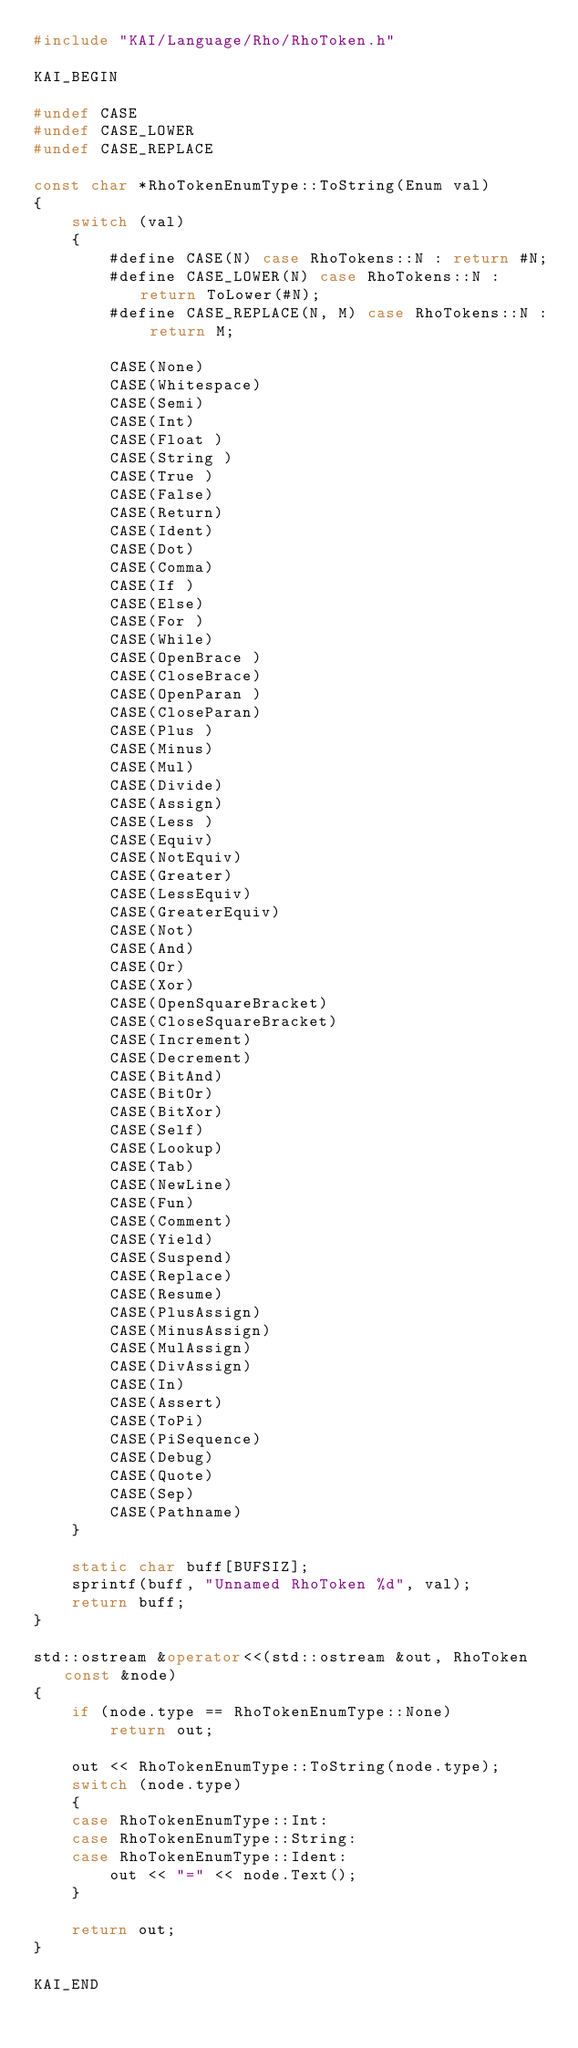Convert code to text. <code><loc_0><loc_0><loc_500><loc_500><_C++_>#include "KAI/Language/Rho/RhoToken.h"

KAI_BEGIN

#undef CASE
#undef CASE_LOWER
#undef CASE_REPLACE

const char *RhoTokenEnumType::ToString(Enum val)
{
	switch (val)
	{
		#define CASE(N) case RhoTokens::N : return #N;
		#define CASE_LOWER(N) case RhoTokens::N : return ToLower(#N);
		#define CASE_REPLACE(N, M) case RhoTokens::N : return M;

		CASE(None)
		CASE(Whitespace)
		CASE(Semi)
		CASE(Int)
		CASE(Float )
		CASE(String )
		CASE(True )
		CASE(False)
		CASE(Return)
		CASE(Ident)
		CASE(Dot)
		CASE(Comma)
		CASE(If )
		CASE(Else)
		CASE(For )
		CASE(While)
		CASE(OpenBrace )
		CASE(CloseBrace)
		CASE(OpenParan )
		CASE(CloseParan)
		CASE(Plus )
		CASE(Minus)
		CASE(Mul)
		CASE(Divide)
		CASE(Assign)
		CASE(Less )
		CASE(Equiv)
		CASE(NotEquiv)
		CASE(Greater)
		CASE(LessEquiv)
		CASE(GreaterEquiv)
		CASE(Not)
		CASE(And)
		CASE(Or)
		CASE(Xor)
		CASE(OpenSquareBracket)
		CASE(CloseSquareBracket)
		CASE(Increment)
		CASE(Decrement)
		CASE(BitAnd)
		CASE(BitOr)
		CASE(BitXor)
		CASE(Self)
		CASE(Lookup)
		CASE(Tab)
		CASE(NewLine)
		CASE(Fun)
		CASE(Comment)
		CASE(Yield)
		CASE(Suspend)
		CASE(Replace)
		CASE(Resume)
		CASE(PlusAssign)
		CASE(MinusAssign)
		CASE(MulAssign)
		CASE(DivAssign)
		CASE(In)
		CASE(Assert)
		CASE(ToPi)
		CASE(PiSequence)
		CASE(Debug)
		CASE(Quote)
		CASE(Sep)
		CASE(Pathname)
	}

	static char buff[BUFSIZ];
	sprintf(buff, "Unnamed RhoToken %d", val);
	return buff;
}

std::ostream &operator<<(std::ostream &out, RhoToken const &node)
{
	if (node.type == RhoTokenEnumType::None)
		return out;

	out << RhoTokenEnumType::ToString(node.type);
	switch (node.type)
	{
	case RhoTokenEnumType::Int:
	case RhoTokenEnumType::String:
	case RhoTokenEnumType::Ident:
		out << "=" << node.Text();
	}

	return out;
}

KAI_END
</code> 